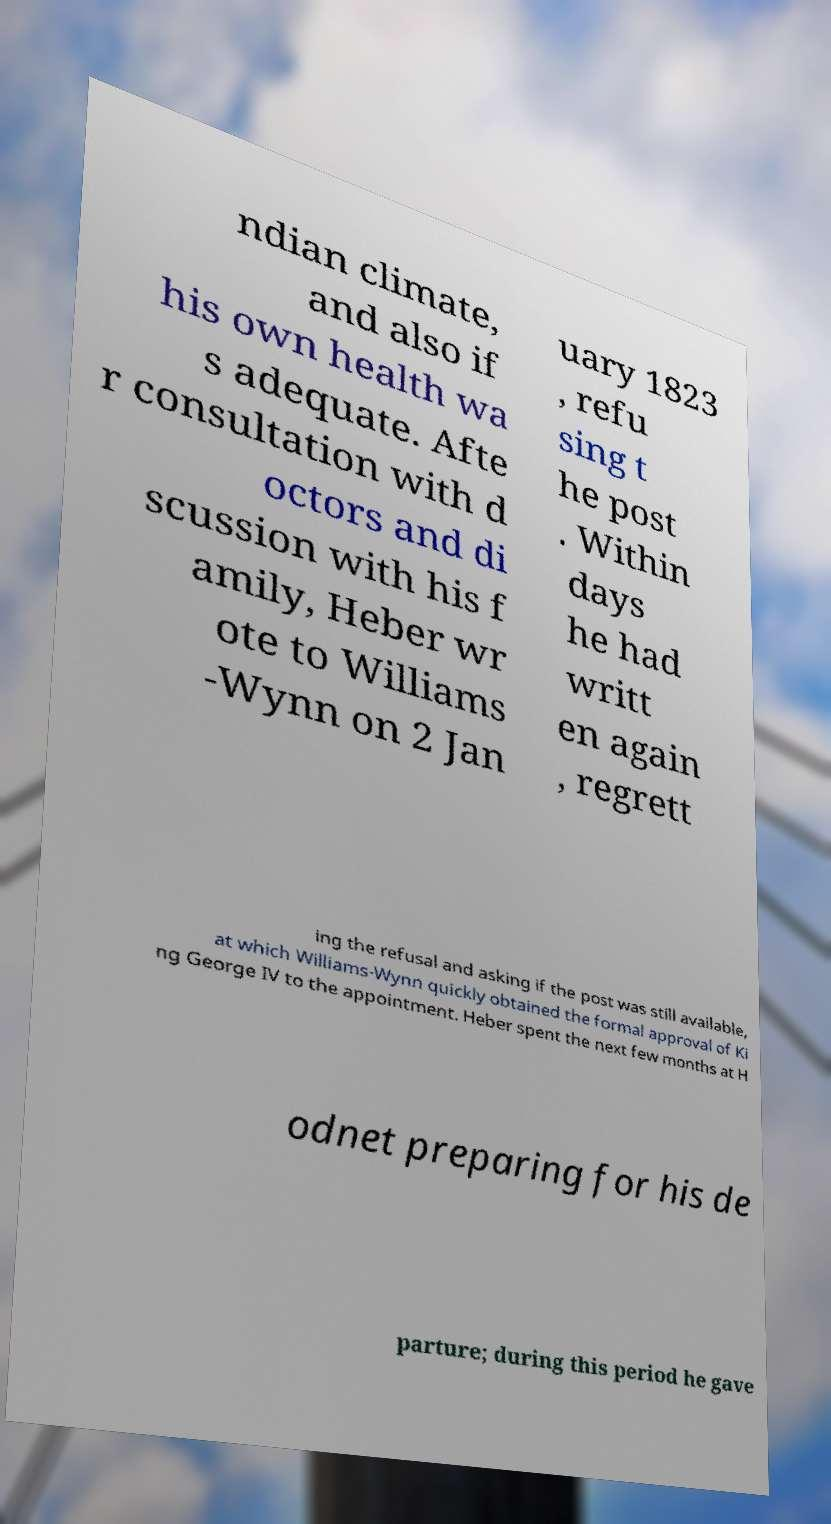What messages or text are displayed in this image? I need them in a readable, typed format. ndian climate, and also if his own health wa s adequate. Afte r consultation with d octors and di scussion with his f amily, Heber wr ote to Williams -Wynn on 2 Jan uary 1823 , refu sing t he post . Within days he had writt en again , regrett ing the refusal and asking if the post was still available, at which Williams-Wynn quickly obtained the formal approval of Ki ng George IV to the appointment. Heber spent the next few months at H odnet preparing for his de parture; during this period he gave 